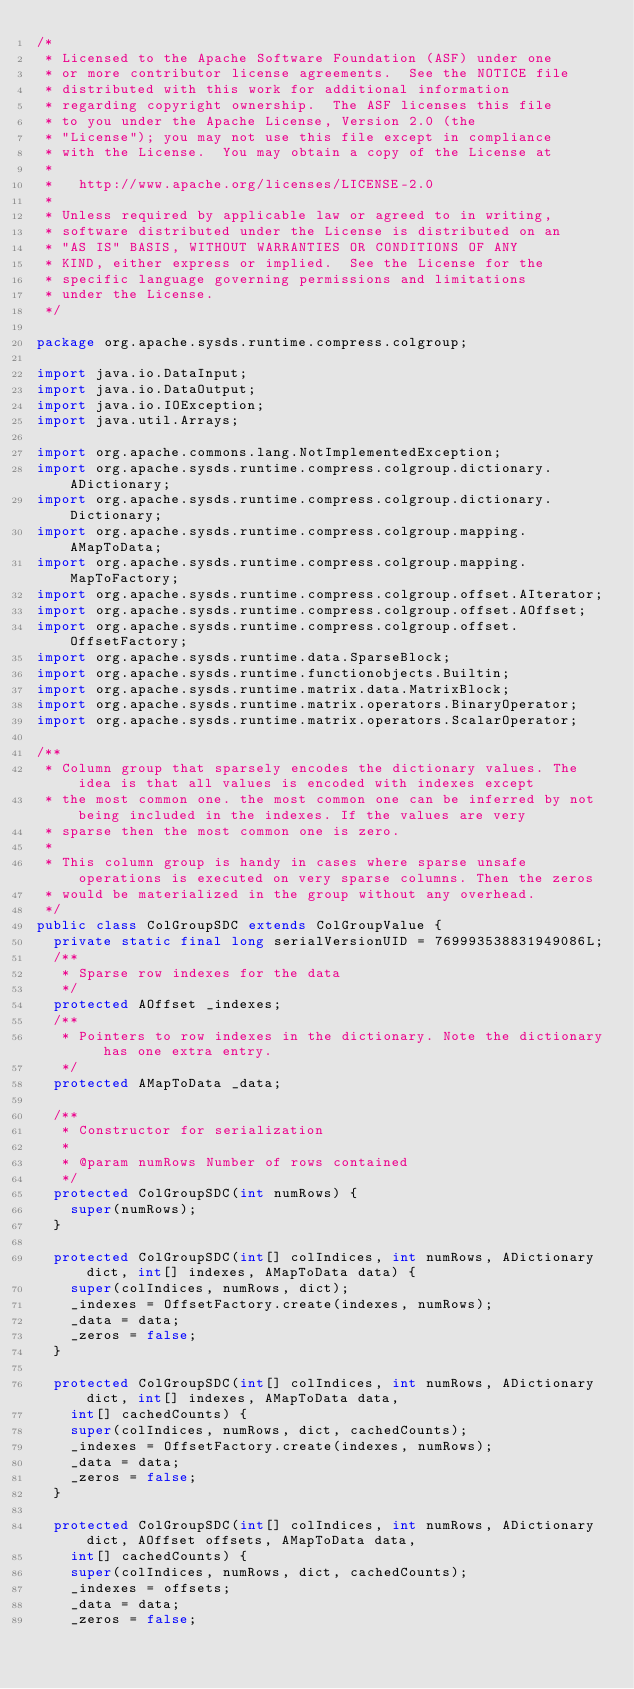<code> <loc_0><loc_0><loc_500><loc_500><_Java_>/*
 * Licensed to the Apache Software Foundation (ASF) under one
 * or more contributor license agreements.  See the NOTICE file
 * distributed with this work for additional information
 * regarding copyright ownership.  The ASF licenses this file
 * to you under the Apache License, Version 2.0 (the
 * "License"); you may not use this file except in compliance
 * with the License.  You may obtain a copy of the License at
 *
 *   http://www.apache.org/licenses/LICENSE-2.0
 *
 * Unless required by applicable law or agreed to in writing,
 * software distributed under the License is distributed on an
 * "AS IS" BASIS, WITHOUT WARRANTIES OR CONDITIONS OF ANY
 * KIND, either express or implied.  See the License for the
 * specific language governing permissions and limitations
 * under the License.
 */

package org.apache.sysds.runtime.compress.colgroup;

import java.io.DataInput;
import java.io.DataOutput;
import java.io.IOException;
import java.util.Arrays;

import org.apache.commons.lang.NotImplementedException;
import org.apache.sysds.runtime.compress.colgroup.dictionary.ADictionary;
import org.apache.sysds.runtime.compress.colgroup.dictionary.Dictionary;
import org.apache.sysds.runtime.compress.colgroup.mapping.AMapToData;
import org.apache.sysds.runtime.compress.colgroup.mapping.MapToFactory;
import org.apache.sysds.runtime.compress.colgroup.offset.AIterator;
import org.apache.sysds.runtime.compress.colgroup.offset.AOffset;
import org.apache.sysds.runtime.compress.colgroup.offset.OffsetFactory;
import org.apache.sysds.runtime.data.SparseBlock;
import org.apache.sysds.runtime.functionobjects.Builtin;
import org.apache.sysds.runtime.matrix.data.MatrixBlock;
import org.apache.sysds.runtime.matrix.operators.BinaryOperator;
import org.apache.sysds.runtime.matrix.operators.ScalarOperator;

/**
 * Column group that sparsely encodes the dictionary values. The idea is that all values is encoded with indexes except
 * the most common one. the most common one can be inferred by not being included in the indexes. If the values are very
 * sparse then the most common one is zero.
 * 
 * This column group is handy in cases where sparse unsafe operations is executed on very sparse columns. Then the zeros
 * would be materialized in the group without any overhead.
 */
public class ColGroupSDC extends ColGroupValue {
	private static final long serialVersionUID = 769993538831949086L;
	/**
	 * Sparse row indexes for the data
	 */
	protected AOffset _indexes;
	/**
	 * Pointers to row indexes in the dictionary. Note the dictionary has one extra entry.
	 */
	protected AMapToData _data;

	/**
	 * Constructor for serialization
	 * 
	 * @param numRows Number of rows contained
	 */
	protected ColGroupSDC(int numRows) {
		super(numRows);
	}

	protected ColGroupSDC(int[] colIndices, int numRows, ADictionary dict, int[] indexes, AMapToData data) {
		super(colIndices, numRows, dict);
		_indexes = OffsetFactory.create(indexes, numRows);
		_data = data;
		_zeros = false;
	}

	protected ColGroupSDC(int[] colIndices, int numRows, ADictionary dict, int[] indexes, AMapToData data,
		int[] cachedCounts) {
		super(colIndices, numRows, dict, cachedCounts);
		_indexes = OffsetFactory.create(indexes, numRows);
		_data = data;
		_zeros = false;
	}

	protected ColGroupSDC(int[] colIndices, int numRows, ADictionary dict, AOffset offsets, AMapToData data,
		int[] cachedCounts) {
		super(colIndices, numRows, dict, cachedCounts);
		_indexes = offsets;
		_data = data;
		_zeros = false;</code> 